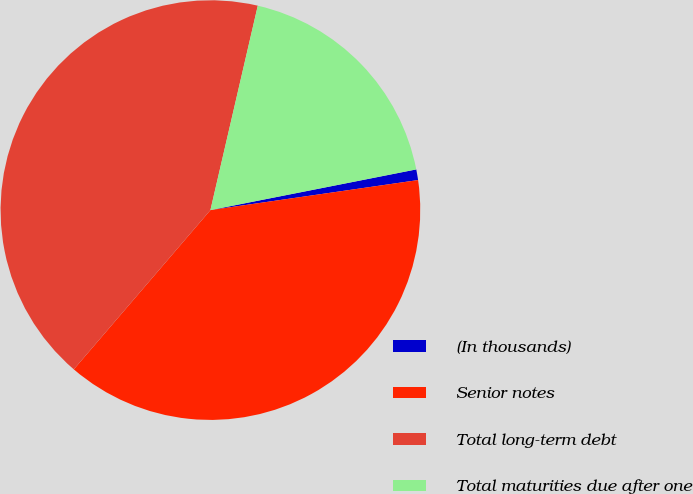<chart> <loc_0><loc_0><loc_500><loc_500><pie_chart><fcel>(In thousands)<fcel>Senior notes<fcel>Total long-term debt<fcel>Total maturities due after one<nl><fcel>0.82%<fcel>38.57%<fcel>42.34%<fcel>18.27%<nl></chart> 